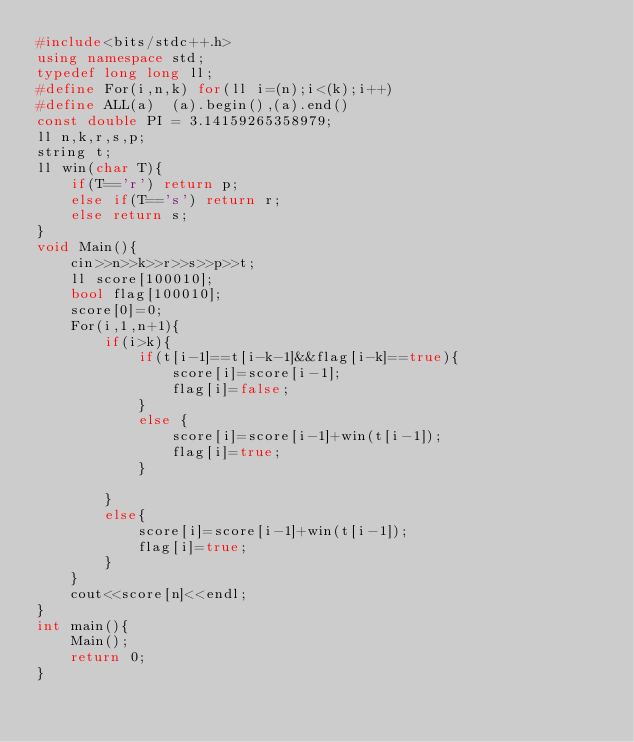Convert code to text. <code><loc_0><loc_0><loc_500><loc_500><_C++_>#include<bits/stdc++.h>
using namespace std;
typedef long long ll;
#define For(i,n,k) for(ll i=(n);i<(k);i++)
#define ALL(a)  (a).begin(),(a).end()
const double PI = 3.14159265358979;
ll n,k,r,s,p;
string t;
ll win(char T){
    if(T=='r') return p;
    else if(T=='s') return r;
    else return s;
}
void Main(){
    cin>>n>>k>>r>>s>>p>>t;
    ll score[100010];
    bool flag[100010];
    score[0]=0;
    For(i,1,n+1){
        if(i>k){
            if(t[i-1]==t[i-k-1]&&flag[i-k]==true){
                score[i]=score[i-1];
                flag[i]=false;
            }
            else {
                score[i]=score[i-1]+win(t[i-1]);
                flag[i]=true;
            }            

        }
        else{
            score[i]=score[i-1]+win(t[i-1]);
            flag[i]=true;
        }
    }
    cout<<score[n]<<endl;
}
int main(){
    Main();
    return 0;
}
</code> 